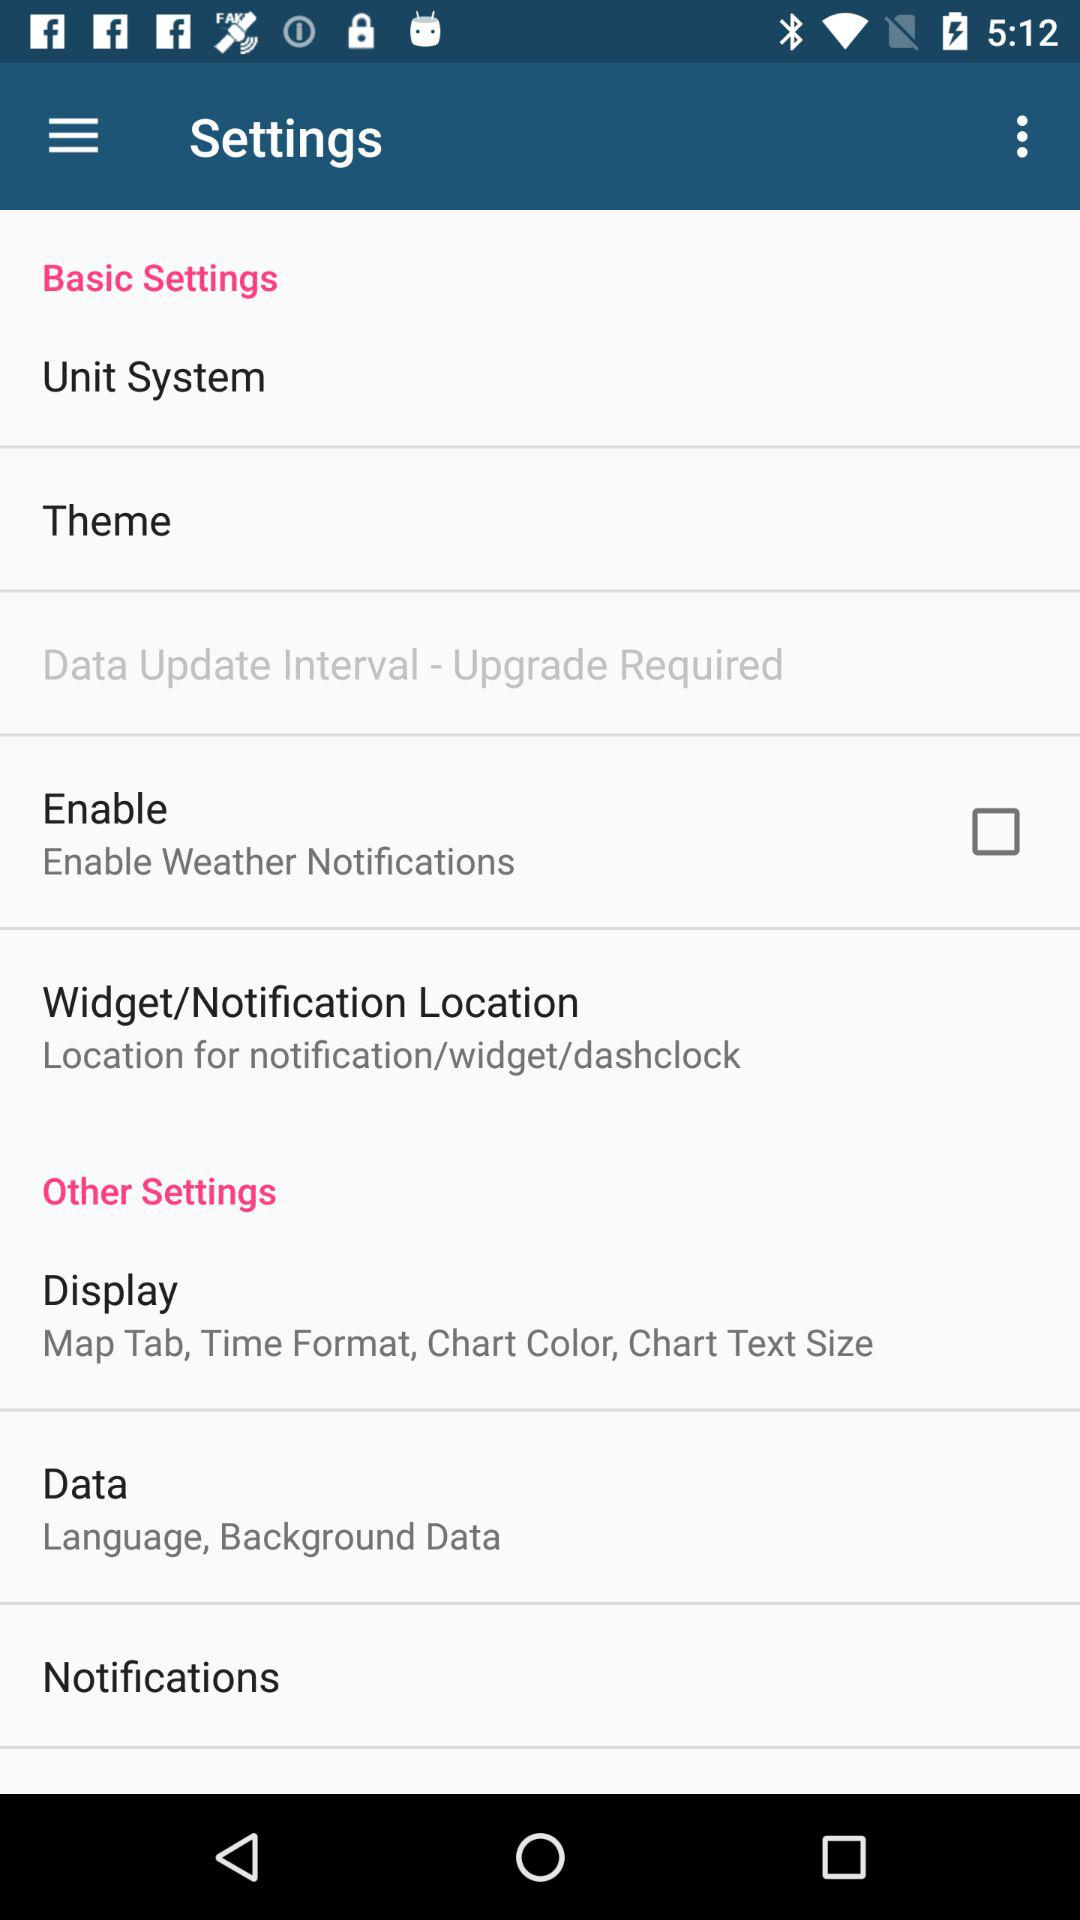Is "Enable Weather Notifications" checked or unchecked? "Enable Weather Notifications" is unchecked. 